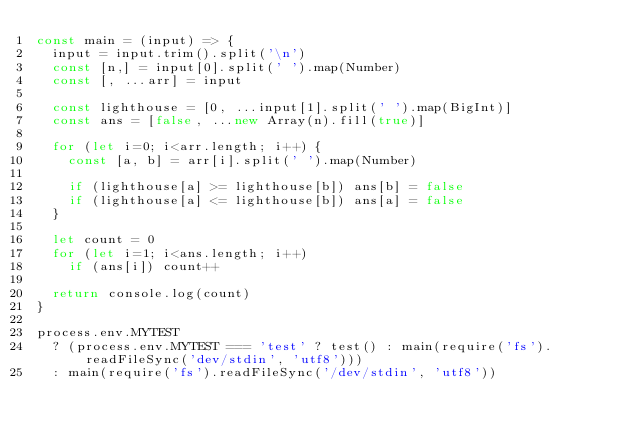<code> <loc_0><loc_0><loc_500><loc_500><_JavaScript_>const main = (input) => {
  input = input.trim().split('\n')
  const [n,] = input[0].split(' ').map(Number)
  const [, ...arr] = input

  const lighthouse = [0, ...input[1].split(' ').map(BigInt)]
  const ans = [false, ...new Array(n).fill(true)]

  for (let i=0; i<arr.length; i++) {
    const [a, b] = arr[i].split(' ').map(Number)

    if (lighthouse[a] >= lighthouse[b]) ans[b] = false
    if (lighthouse[a] <= lighthouse[b]) ans[a] = false
  }

  let count = 0
  for (let i=1; i<ans.length; i++)
    if (ans[i]) count++

  return console.log(count)
}

process.env.MYTEST
  ? (process.env.MYTEST === 'test' ? test() : main(require('fs').readFileSync('dev/stdin', 'utf8')))
  : main(require('fs').readFileSync('/dev/stdin', 'utf8'))</code> 